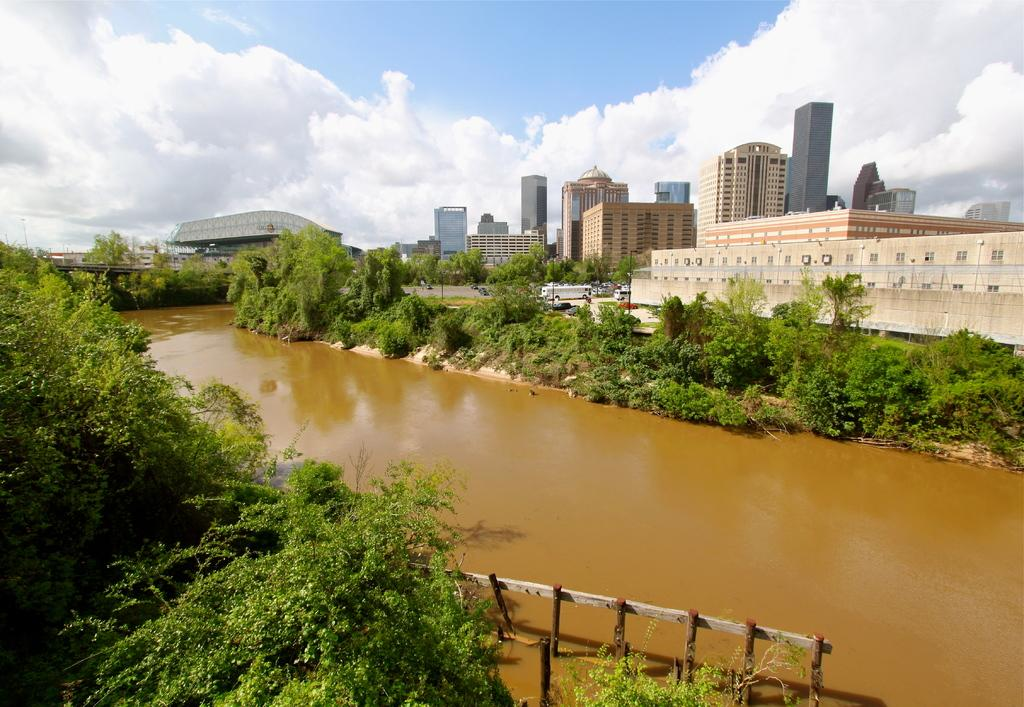What type of natural elements are near the water in the image? There are plants and trees near the water in the image. How would you describe the sky in the image? The sky is cloudy in the image. What can be seen in the background of the image? There are buildings and vehicles present in the background. What holiday is being celebrated in the image? There is no indication of a holiday being celebrated in the image. What hopeful message can be seen on the trees in the image? There is no message visible on the trees in the image. 